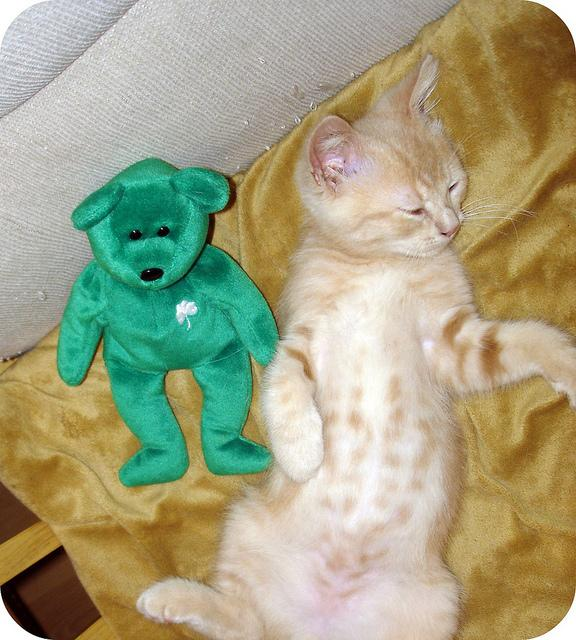What is the logo on the bear? Please explain your reasoning. shamrock. A four leaf clover is sometimes also referred to as a shamrock. 